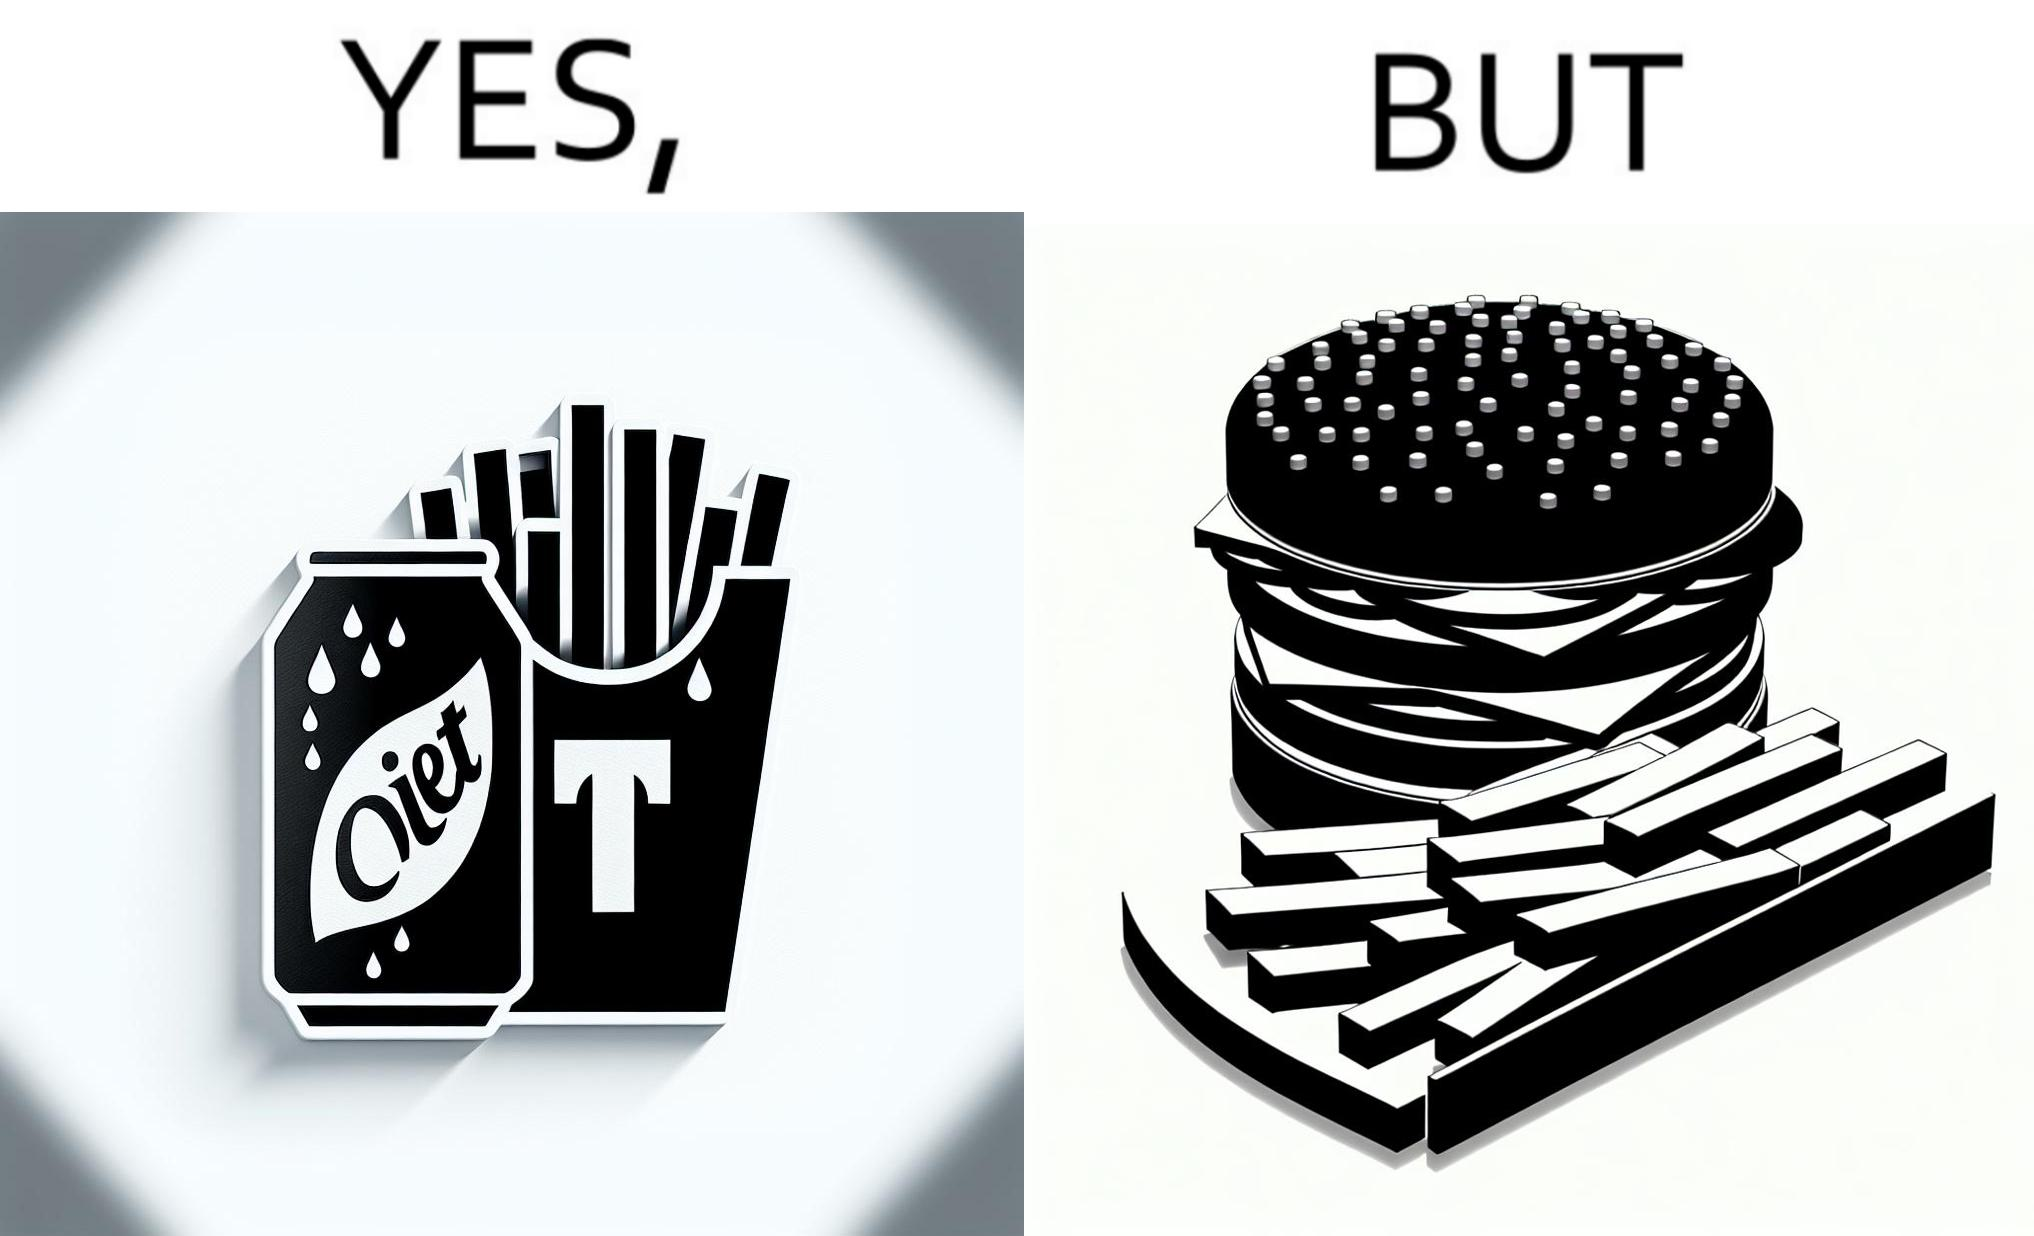What does this image depict? The image is ironic, because on one hand the person is consuming diet cola suggesting low on sugar as per label meaning the person is health-conscious but on the other hand the same one is having huge size burger with french fries which suggests the person to be health-ignorant 